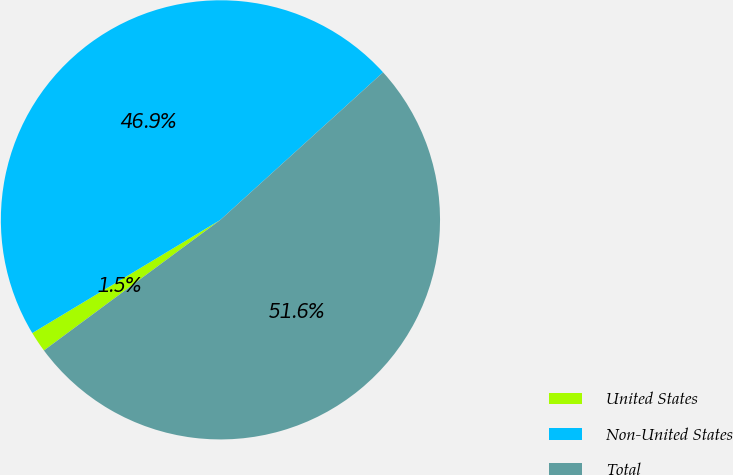Convert chart to OTSL. <chart><loc_0><loc_0><loc_500><loc_500><pie_chart><fcel>United States<fcel>Non-United States<fcel>Total<nl><fcel>1.52%<fcel>46.9%<fcel>51.59%<nl></chart> 